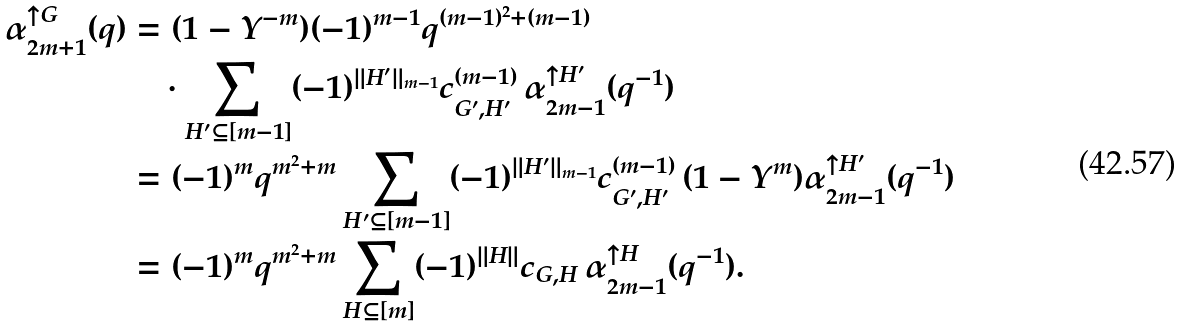Convert formula to latex. <formula><loc_0><loc_0><loc_500><loc_500>\alpha _ { 2 m + 1 } ^ { \uparrow G } ( q ) & = ( 1 - Y ^ { - m } ) ( - 1 ) ^ { m - 1 } q ^ { ( m - 1 ) ^ { 2 } + ( m - 1 ) } \\ & \quad \cdot \sum _ { H ^ { \prime } \subseteq [ m - 1 ] } ( - 1 ) ^ { \| H ^ { \prime } \| _ { m - 1 } } c _ { G ^ { \prime } , H ^ { \prime } } ^ { ( m - 1 ) } \, \alpha _ { 2 m - 1 } ^ { \uparrow H ^ { \prime } } ( q ^ { - 1 } ) \\ & = ( - 1 ) ^ { m } q ^ { m ^ { 2 } + m } \sum _ { H ^ { \prime } \subseteq [ m - 1 ] } ( - 1 ) ^ { \| H ^ { \prime } \| _ { m - 1 } } c _ { G ^ { \prime } , H ^ { \prime } } ^ { ( m - 1 ) } \, ( 1 - Y ^ { m } ) \alpha _ { 2 m - 1 } ^ { \uparrow H ^ { \prime } } ( q ^ { - 1 } ) \\ & = ( - 1 ) ^ { m } q ^ { m ^ { 2 } + m } \sum _ { H \subseteq [ m ] } ( - 1 ) ^ { \| H \| } c _ { G , H } \, \alpha _ { 2 m - 1 } ^ { \uparrow H } ( q ^ { - 1 } ) .</formula> 